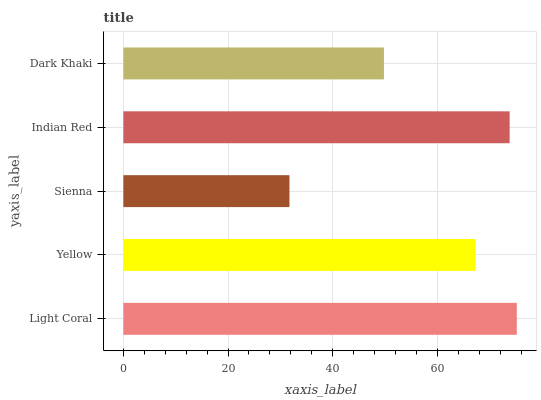Is Sienna the minimum?
Answer yes or no. Yes. Is Light Coral the maximum?
Answer yes or no. Yes. Is Yellow the minimum?
Answer yes or no. No. Is Yellow the maximum?
Answer yes or no. No. Is Light Coral greater than Yellow?
Answer yes or no. Yes. Is Yellow less than Light Coral?
Answer yes or no. Yes. Is Yellow greater than Light Coral?
Answer yes or no. No. Is Light Coral less than Yellow?
Answer yes or no. No. Is Yellow the high median?
Answer yes or no. Yes. Is Yellow the low median?
Answer yes or no. Yes. Is Sienna the high median?
Answer yes or no. No. Is Light Coral the low median?
Answer yes or no. No. 